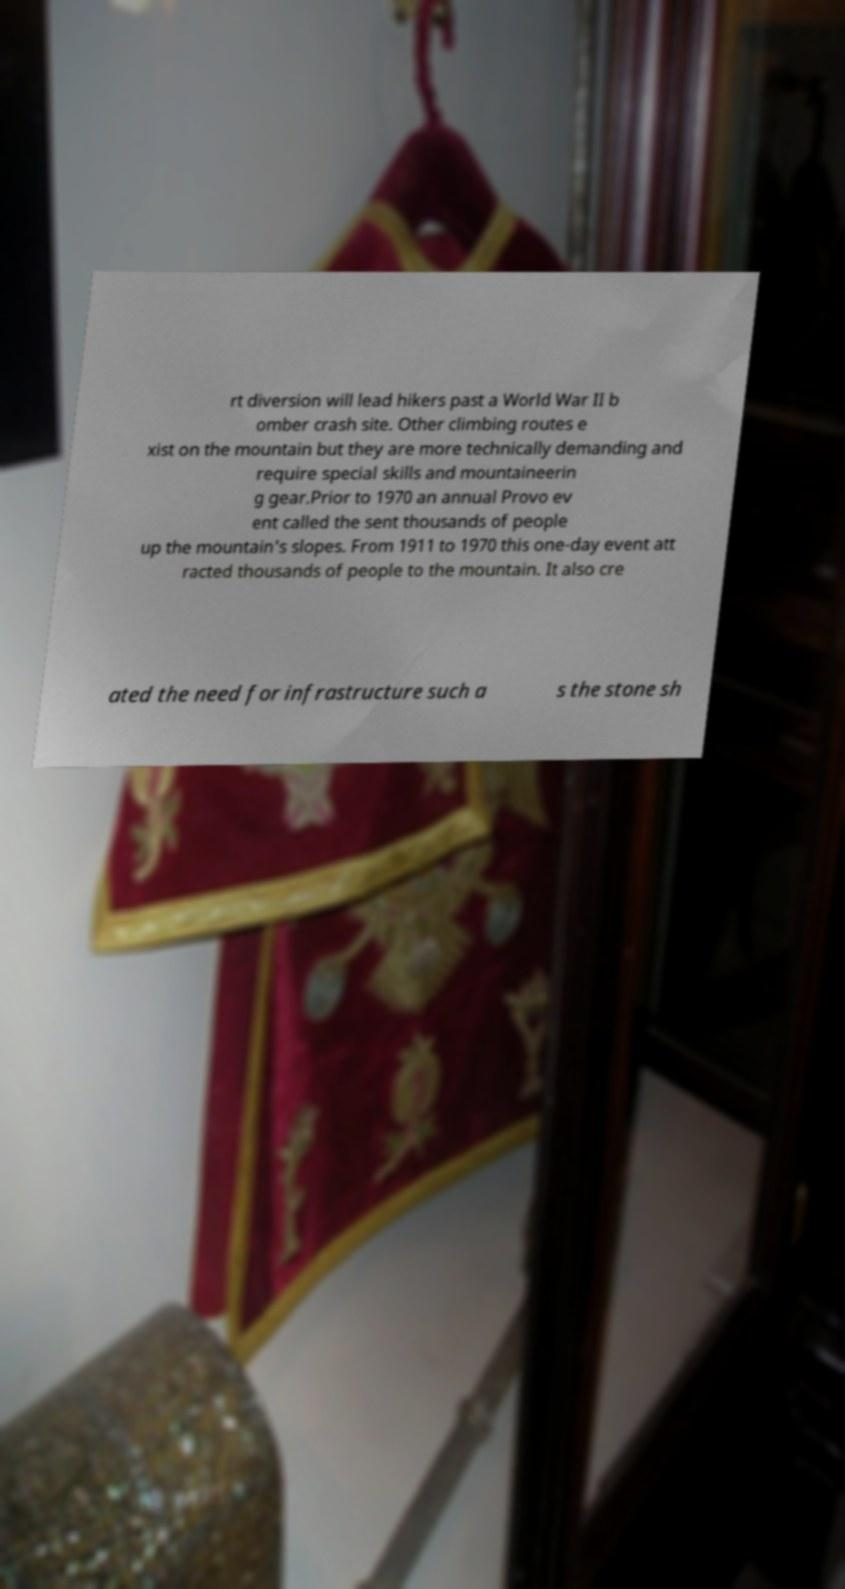Could you assist in decoding the text presented in this image and type it out clearly? rt diversion will lead hikers past a World War II b omber crash site. Other climbing routes e xist on the mountain but they are more technically demanding and require special skills and mountaineerin g gear.Prior to 1970 an annual Provo ev ent called the sent thousands of people up the mountain's slopes. From 1911 to 1970 this one-day event att racted thousands of people to the mountain. It also cre ated the need for infrastructure such a s the stone sh 